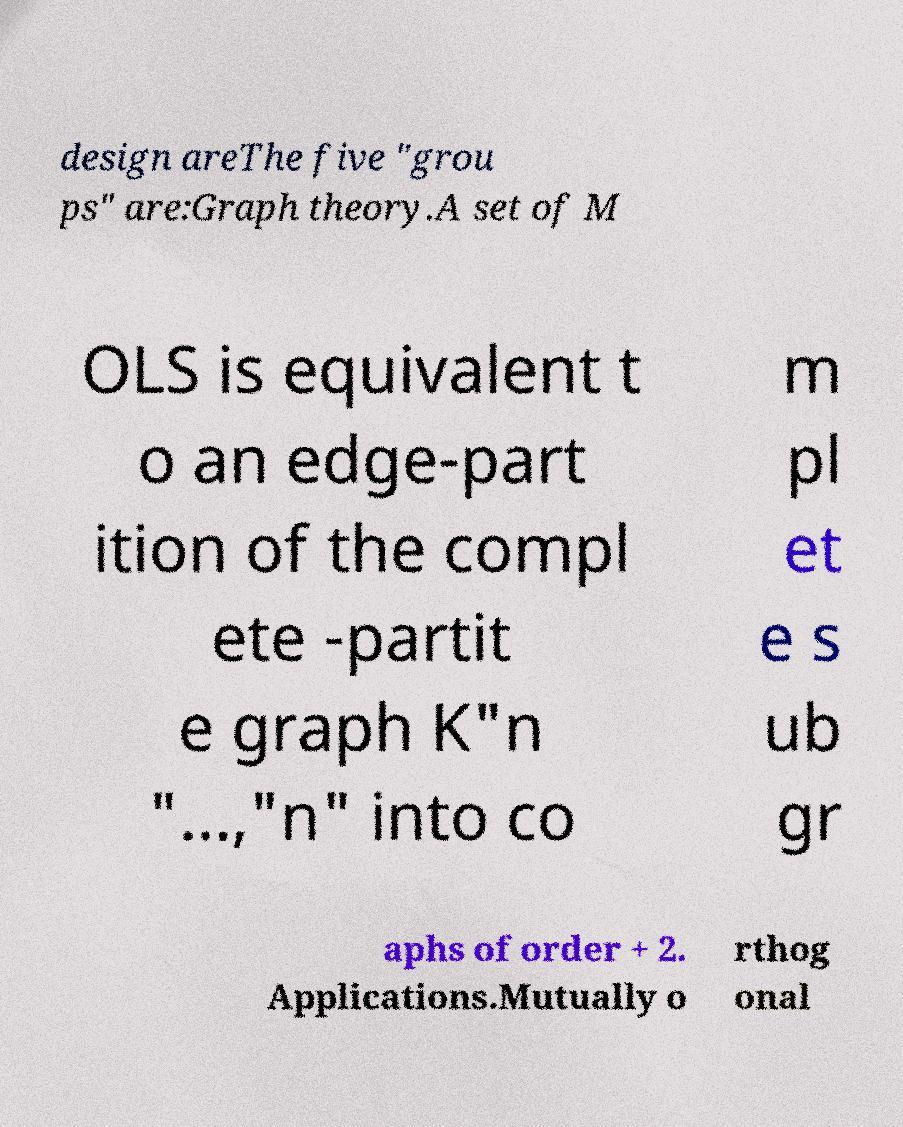I need the written content from this picture converted into text. Can you do that? design areThe five "grou ps" are:Graph theory.A set of M OLS is equivalent t o an edge-part ition of the compl ete -partit e graph K"n "...,"n" into co m pl et e s ub gr aphs of order + 2. Applications.Mutually o rthog onal 